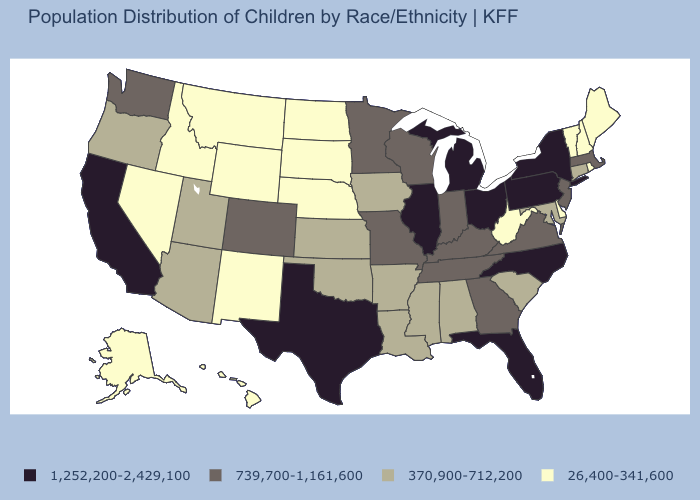Does Pennsylvania have a higher value than Texas?
Answer briefly. No. Which states have the lowest value in the USA?
Quick response, please. Alaska, Delaware, Hawaii, Idaho, Maine, Montana, Nebraska, Nevada, New Hampshire, New Mexico, North Dakota, Rhode Island, South Dakota, Vermont, West Virginia, Wyoming. Which states hav the highest value in the MidWest?
Short answer required. Illinois, Michigan, Ohio. What is the value of North Carolina?
Give a very brief answer. 1,252,200-2,429,100. What is the value of Wyoming?
Quick response, please. 26,400-341,600. Does the map have missing data?
Concise answer only. No. Does Louisiana have a lower value than California?
Give a very brief answer. Yes. Which states have the lowest value in the South?
Be succinct. Delaware, West Virginia. Does Minnesota have a higher value than Ohio?
Answer briefly. No. How many symbols are there in the legend?
Be succinct. 4. What is the value of New Jersey?
Short answer required. 739,700-1,161,600. Does Massachusetts have the lowest value in the Northeast?
Write a very short answer. No. What is the value of North Dakota?
Be succinct. 26,400-341,600. Name the states that have a value in the range 1,252,200-2,429,100?
Quick response, please. California, Florida, Illinois, Michigan, New York, North Carolina, Ohio, Pennsylvania, Texas. 